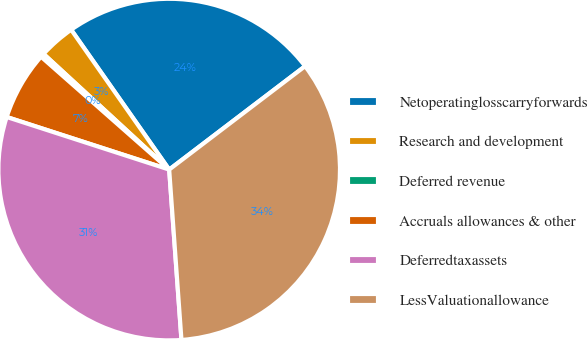Convert chart to OTSL. <chart><loc_0><loc_0><loc_500><loc_500><pie_chart><fcel>Netoperatinglosscarryforwards<fcel>Research and development<fcel>Deferred revenue<fcel>Accruals allowances & other<fcel>Deferredtaxassets<fcel>LessValuationallowance<nl><fcel>24.38%<fcel>3.43%<fcel>0.35%<fcel>6.51%<fcel>31.13%<fcel>34.21%<nl></chart> 